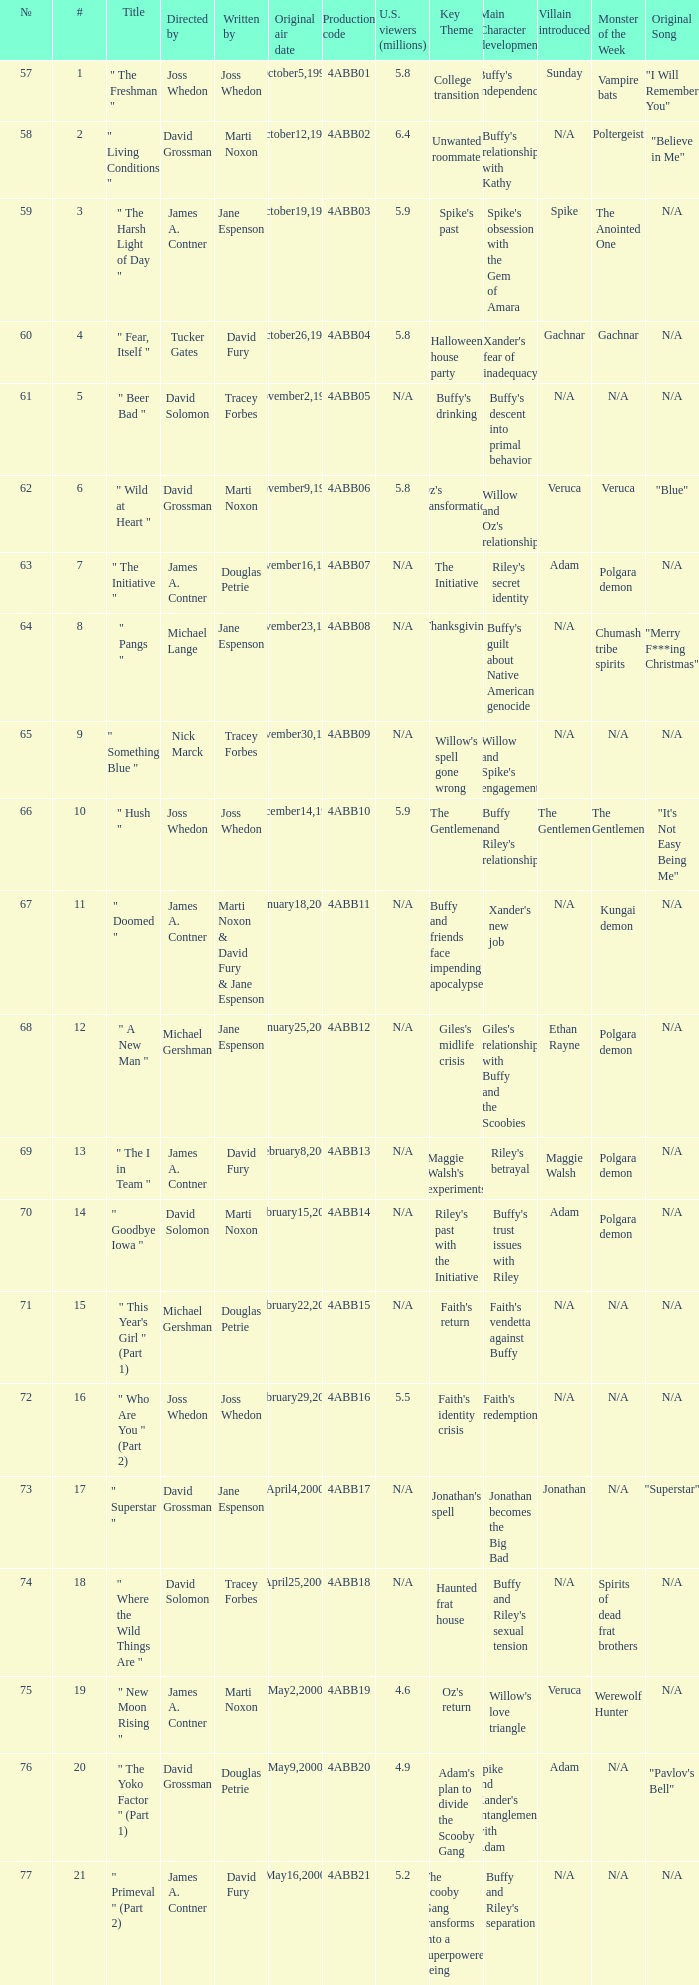What is the production code for the episode with 5.5 million u.s. viewers? 4ABB16. 